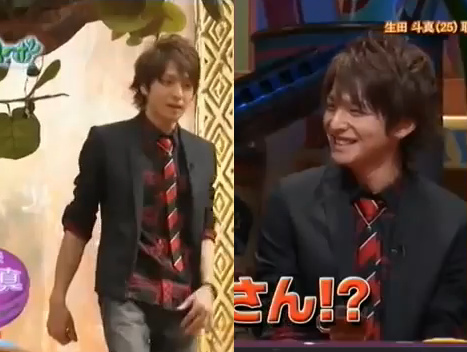Is the man that is not old wearing a watch? Yes, the younger man is indeed wearing a watch. 